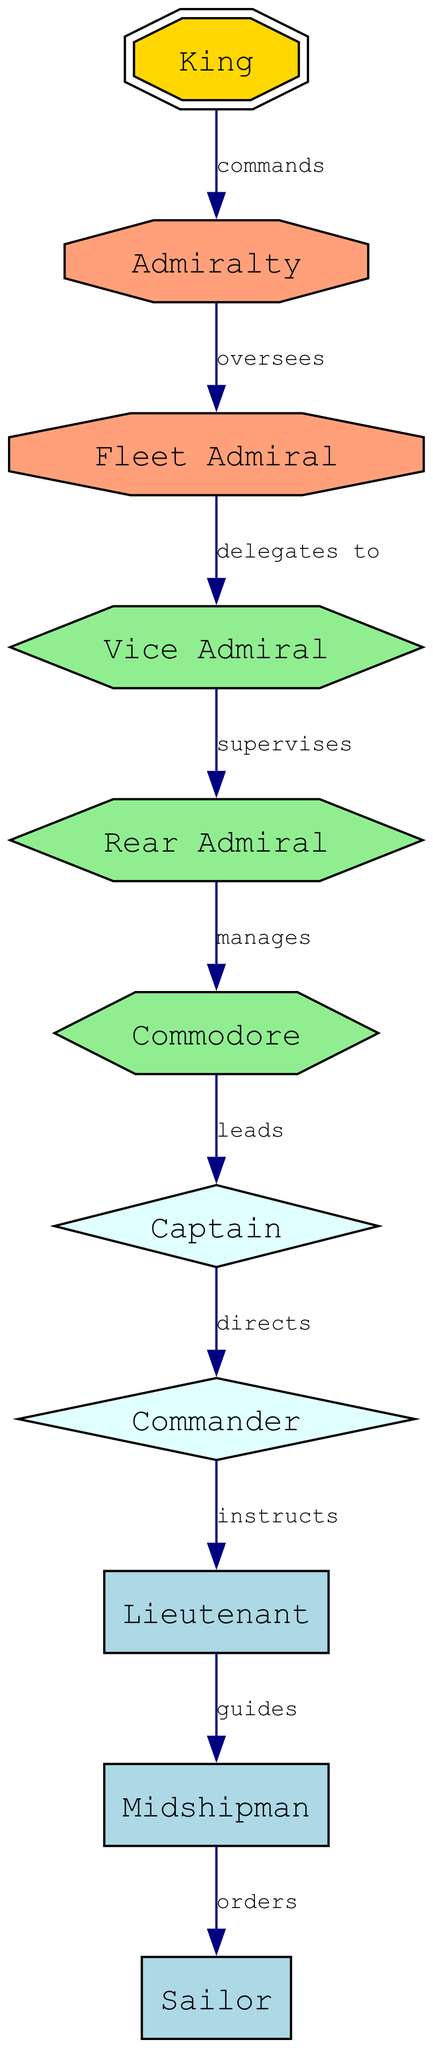What is the highest rank in the hierarchy? The highest rank is represented by the node labeled "King." In the diagram, this is the top node, indicating the ultimate authority in the naval command structure.
Answer: King Who does the Fleet Admiral delegate to? The diagram shows that the Fleet Admiral delegates to the Vice Admiral, as indicated by the directed edge leading to the respective node labeled "Vice Admiral."
Answer: Vice Admiral How many nodes are there in total? The diagram includes a total of 11 nodes, each representing a rank or position within the naval command hierarchy.
Answer: 11 What is the relationship between the Commodore and the Captain? In the diagram, the relationship is defined by the edge labeled "leads," indicating that the Commodore leads the Captain. This establishes the chain of command between these two ranks.
Answer: leads What position does the Admiral oversee? According to the diagram, the Admiralty oversees the Fleet Admiral, which indicates that the Admiralty holds a supervisory role over this rank.
Answer: Fleet Admiral Which rank is guided by the Lieutenant? The diagram indicates that the Lieutenant guides the Midshipman. This is represented by a directed edge that illustrates the mentorship role of the Lieutenant in this context.
Answer: Midshipman How does the Rear Admiral interact with the Commodore? The diagram shows that the Rear Admiral manages the Commodore, which signifies a direct managerial relationship where tasks and oversight flow from the Rear Admiral to the Commodore.
Answer: manages Who is ordered by the Midshipman? The diagram depicts that the Sailor is ordered by the Midshipman, highlighting the hierarchical command where the Midshipman has authority over this rank.
Answer: Sailor Which rank is the immediate superior to the Commander? The diagram indicates that the immediate superior to the Commander is the Captain, as shown by the directed edge that flows from Captain to Commander, demonstrating a clear line of command.
Answer: Captain 